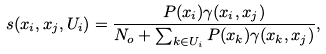Convert formula to latex. <formula><loc_0><loc_0><loc_500><loc_500>s ( x _ { i } , x _ { j } , U _ { i } ) = \frac { P ( x _ { i } ) \gamma ( x _ { i } , x _ { j } ) } { N _ { o } + \sum _ { k \in U _ { i } } P ( x _ { k } ) \gamma ( x _ { k } , x _ { j } ) } ,</formula> 